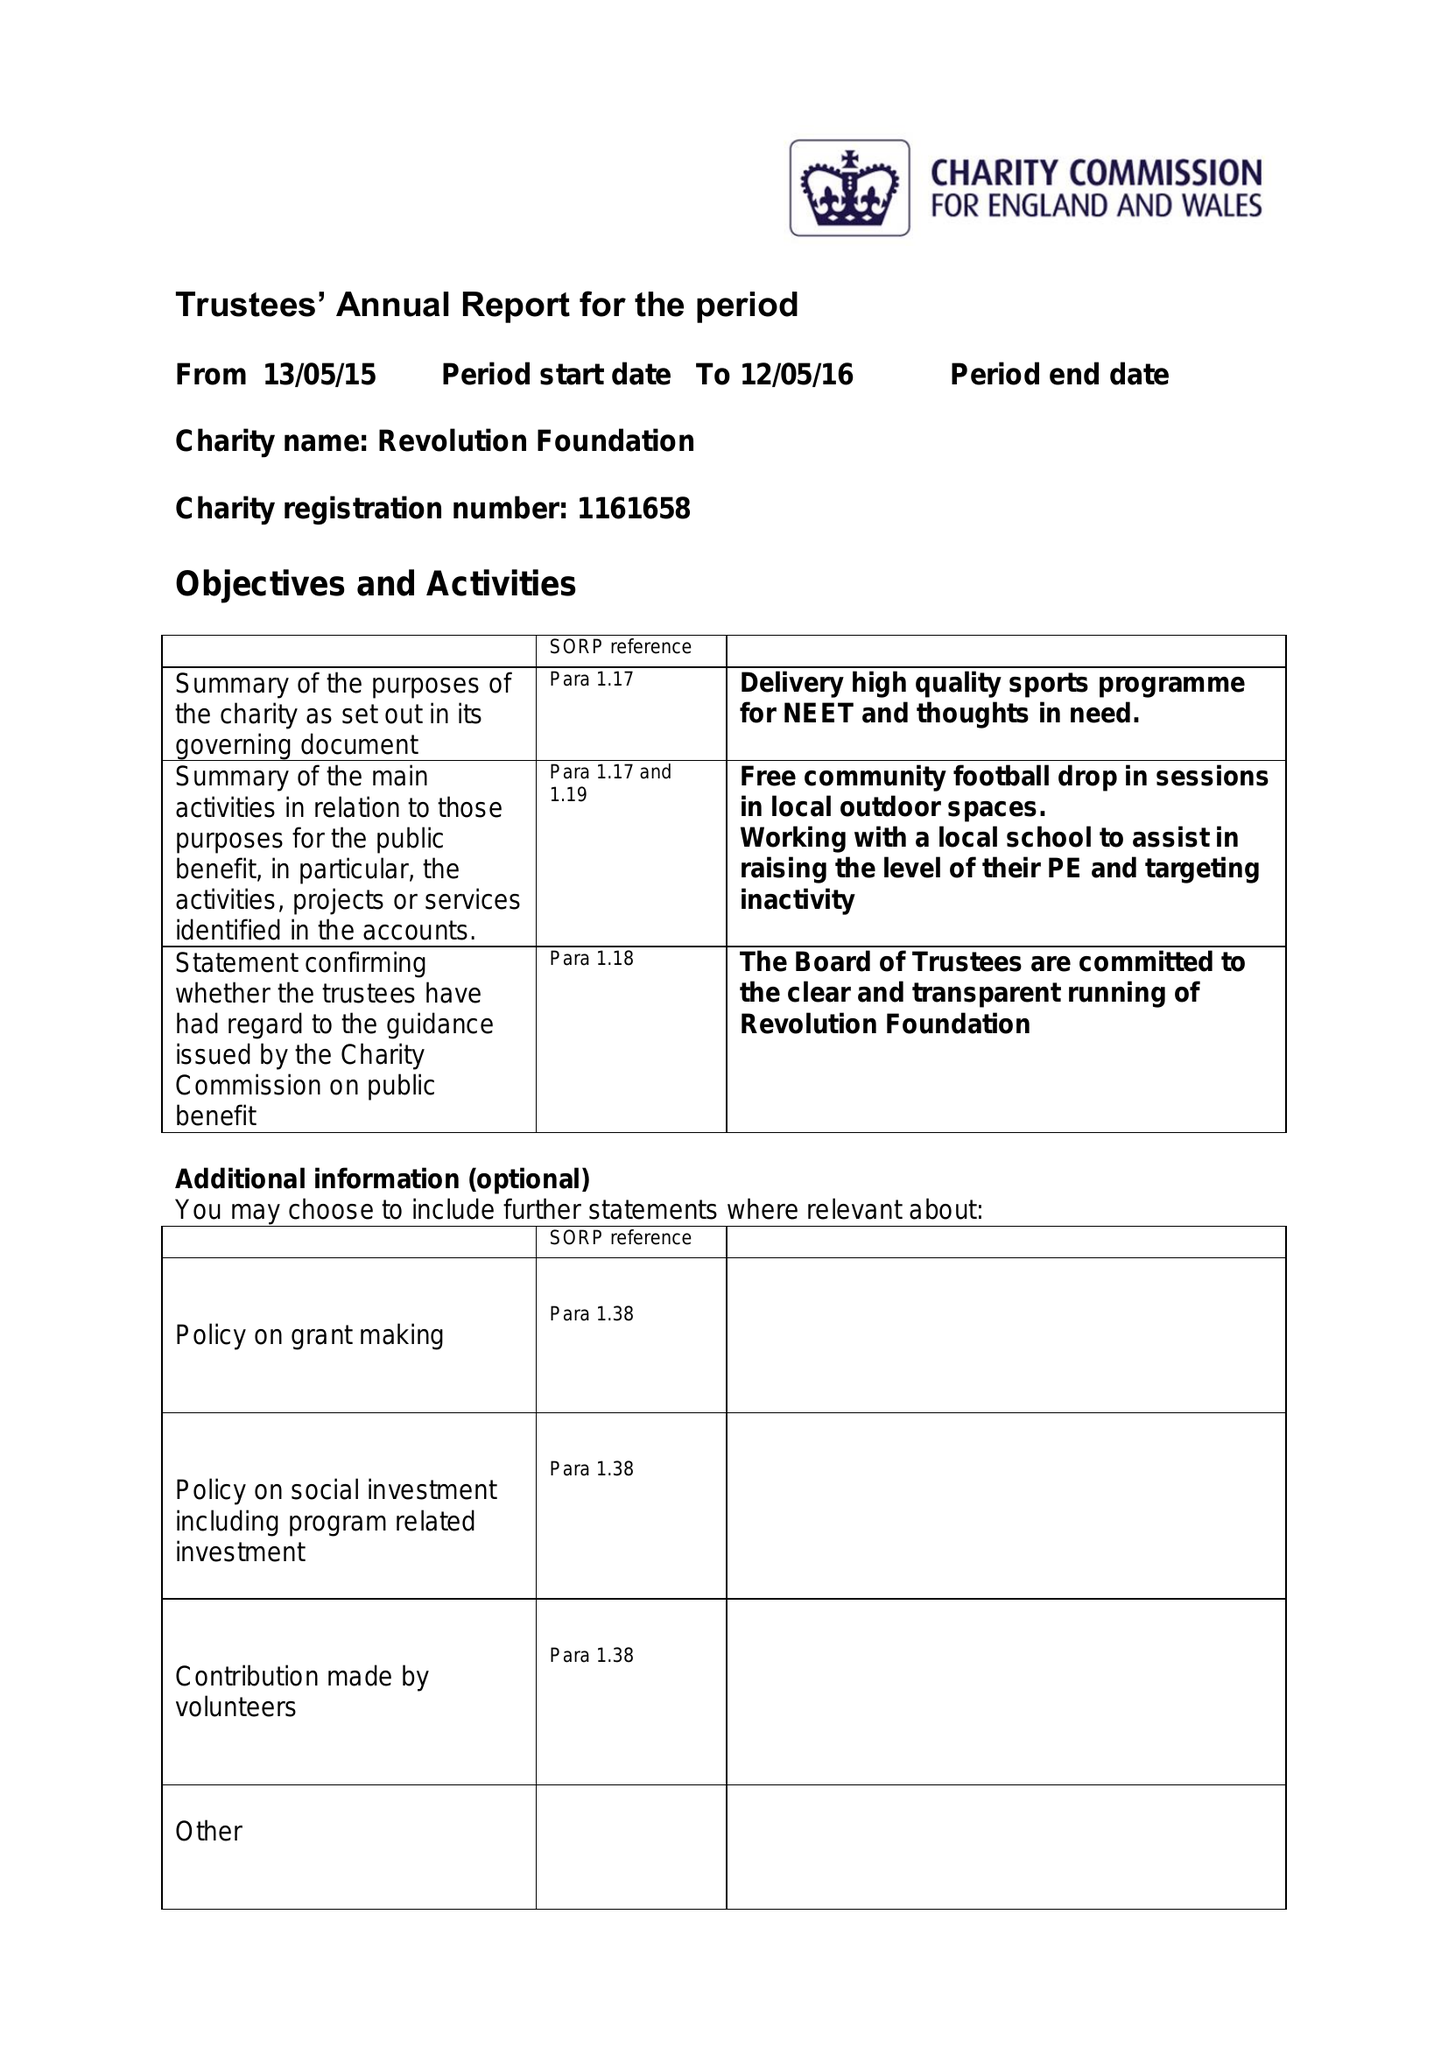What is the value for the report_date?
Answer the question using a single word or phrase. 2016-05-12 